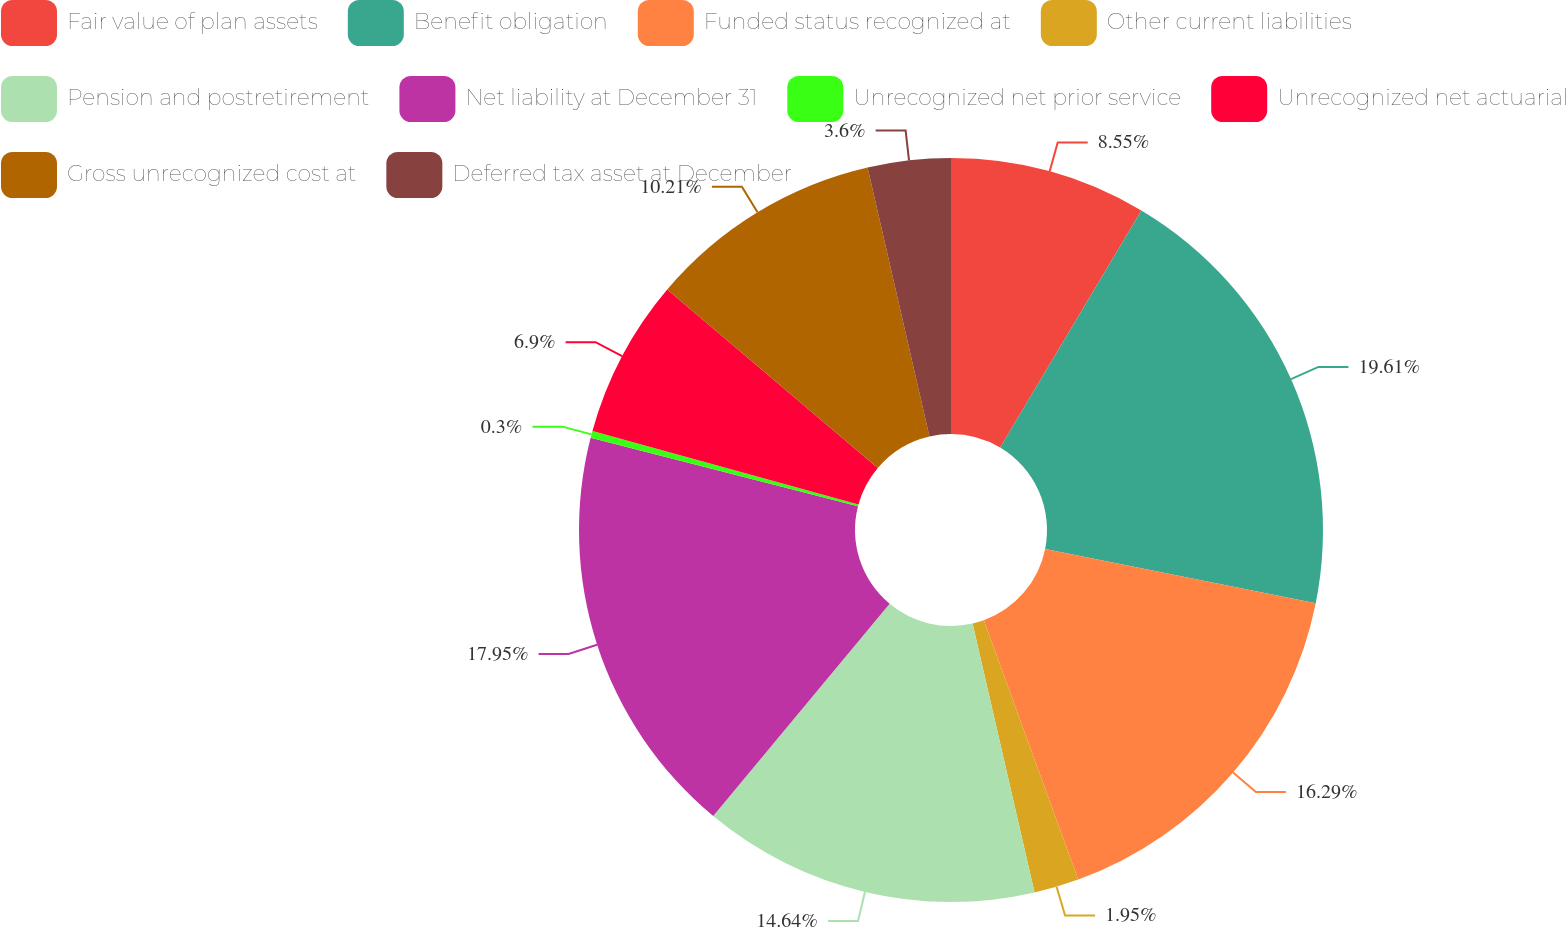Convert chart to OTSL. <chart><loc_0><loc_0><loc_500><loc_500><pie_chart><fcel>Fair value of plan assets<fcel>Benefit obligation<fcel>Funded status recognized at<fcel>Other current liabilities<fcel>Pension and postretirement<fcel>Net liability at December 31<fcel>Unrecognized net prior service<fcel>Unrecognized net actuarial<fcel>Gross unrecognized cost at<fcel>Deferred tax asset at December<nl><fcel>8.55%<fcel>19.6%<fcel>16.29%<fcel>1.95%<fcel>14.64%<fcel>17.95%<fcel>0.3%<fcel>6.9%<fcel>10.21%<fcel>3.6%<nl></chart> 